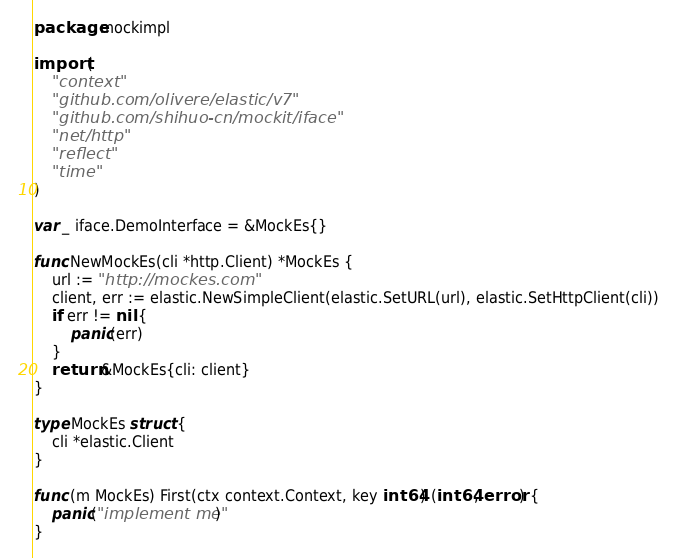<code> <loc_0><loc_0><loc_500><loc_500><_Go_>package mockimpl

import (
	"context"
	"github.com/olivere/elastic/v7"
	"github.com/shihuo-cn/mockit/iface"
	"net/http"
	"reflect"
	"time"
)

var _ iface.DemoInterface = &MockEs{}

func NewMockEs(cli *http.Client) *MockEs {
	url := "http://mockes.com"
	client, err := elastic.NewSimpleClient(elastic.SetURL(url), elastic.SetHttpClient(cli))
	if err != nil {
		panic(err)
	}
	return &MockEs{cli: client}
}

type MockEs struct {
	cli *elastic.Client
}

func (m MockEs) First(ctx context.Context, key int64) (int64, error) {
	panic("implement me")
}
</code> 